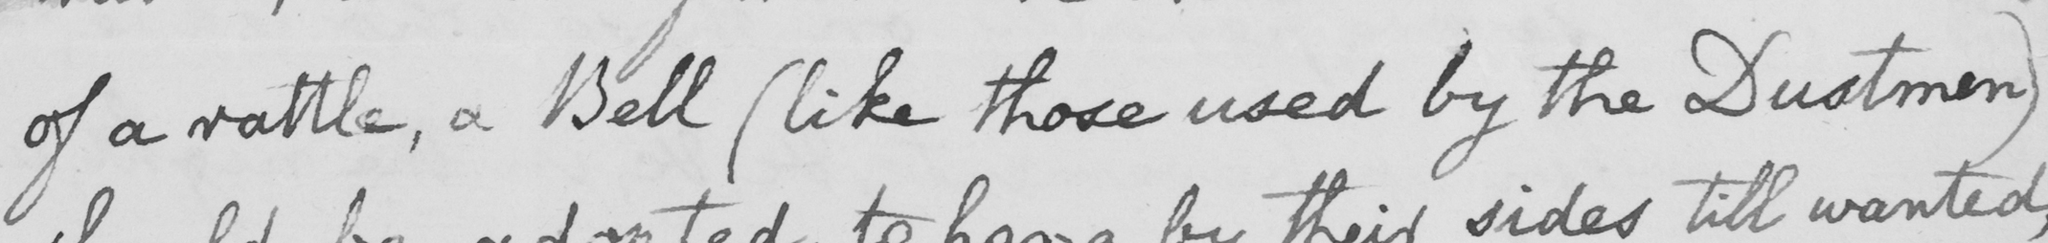Can you read and transcribe this handwriting? of a rattle , a Bell  ( like those used by the Dustmen ) 